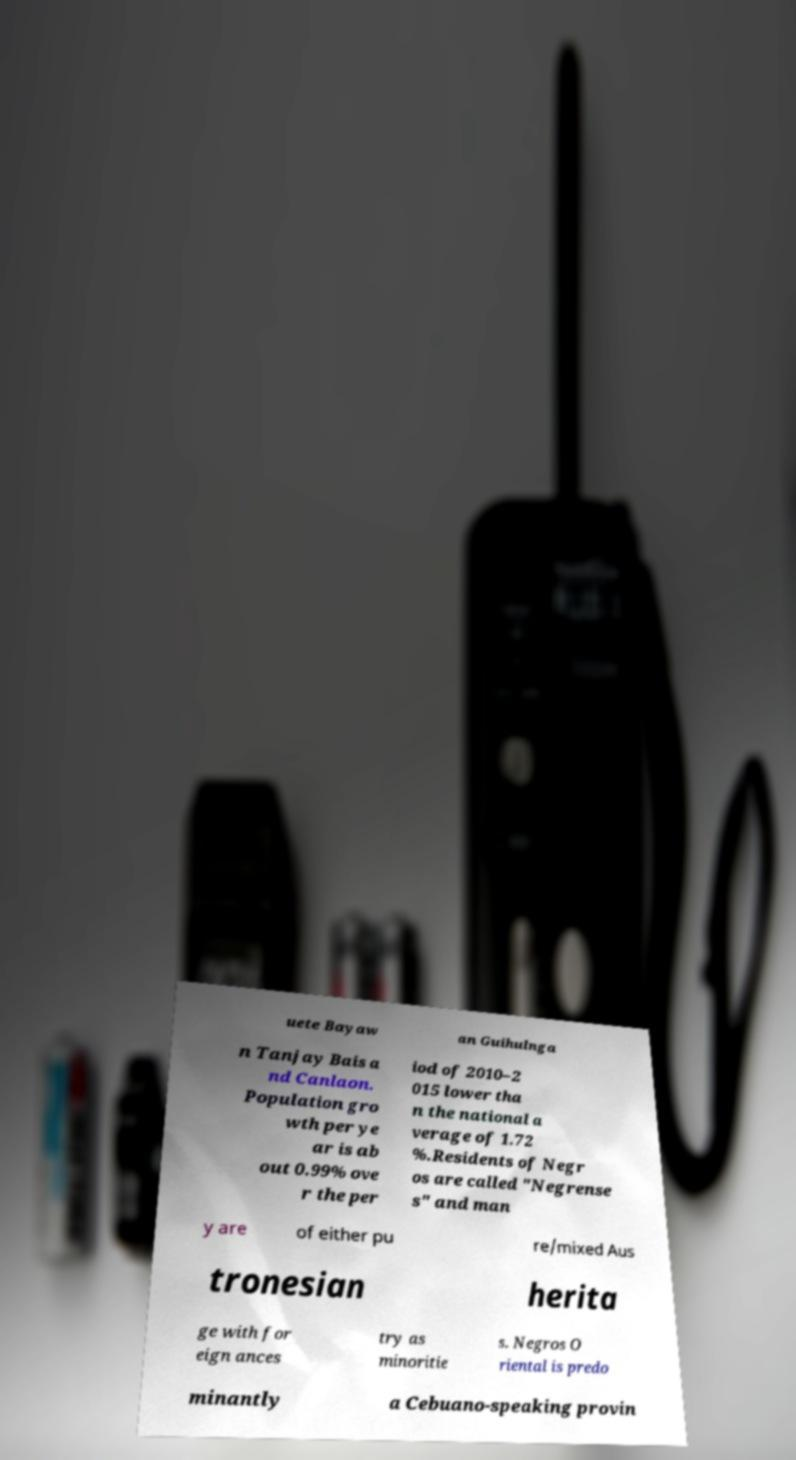Can you read and provide the text displayed in the image?This photo seems to have some interesting text. Can you extract and type it out for me? uete Bayaw an Guihulnga n Tanjay Bais a nd Canlaon. Population gro wth per ye ar is ab out 0.99% ove r the per iod of 2010–2 015 lower tha n the national a verage of 1.72 %.Residents of Negr os are called "Negrense s" and man y are of either pu re/mixed Aus tronesian herita ge with for eign ances try as minoritie s. Negros O riental is predo minantly a Cebuano-speaking provin 